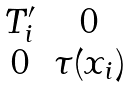<formula> <loc_0><loc_0><loc_500><loc_500>\begin{matrix} T ^ { \prime } _ { i } & 0 \\ 0 & \tau ( x _ { i } ) \end{matrix}</formula> 